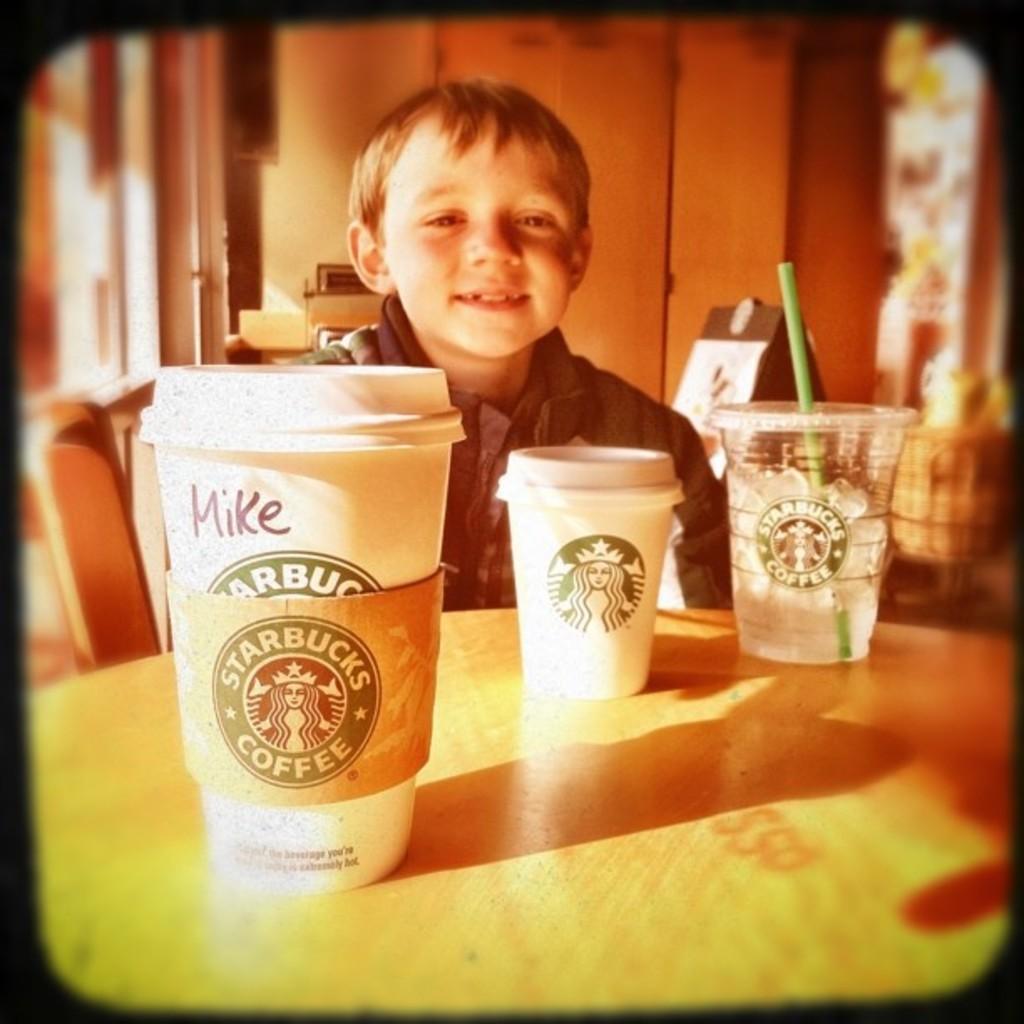Whose name is written on the cup on the left?
Keep it short and to the point. Mike. What coffee shop is this at?
Offer a terse response. Starbucks. 